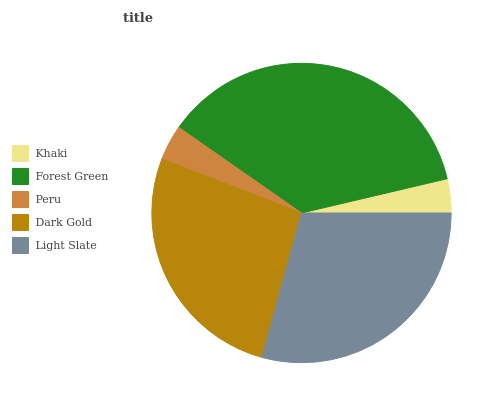Is Khaki the minimum?
Answer yes or no. Yes. Is Forest Green the maximum?
Answer yes or no. Yes. Is Peru the minimum?
Answer yes or no. No. Is Peru the maximum?
Answer yes or no. No. Is Forest Green greater than Peru?
Answer yes or no. Yes. Is Peru less than Forest Green?
Answer yes or no. Yes. Is Peru greater than Forest Green?
Answer yes or no. No. Is Forest Green less than Peru?
Answer yes or no. No. Is Dark Gold the high median?
Answer yes or no. Yes. Is Dark Gold the low median?
Answer yes or no. Yes. Is Khaki the high median?
Answer yes or no. No. Is Khaki the low median?
Answer yes or no. No. 